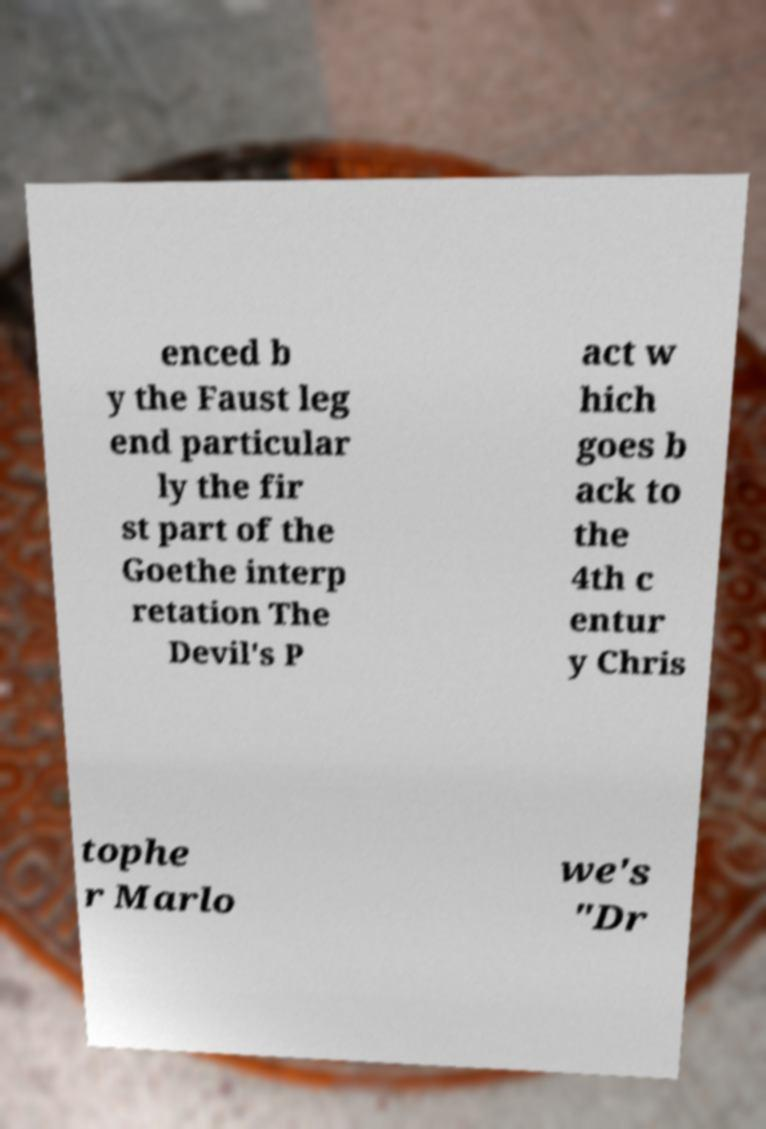For documentation purposes, I need the text within this image transcribed. Could you provide that? enced b y the Faust leg end particular ly the fir st part of the Goethe interp retation The Devil's P act w hich goes b ack to the 4th c entur y Chris tophe r Marlo we's "Dr 